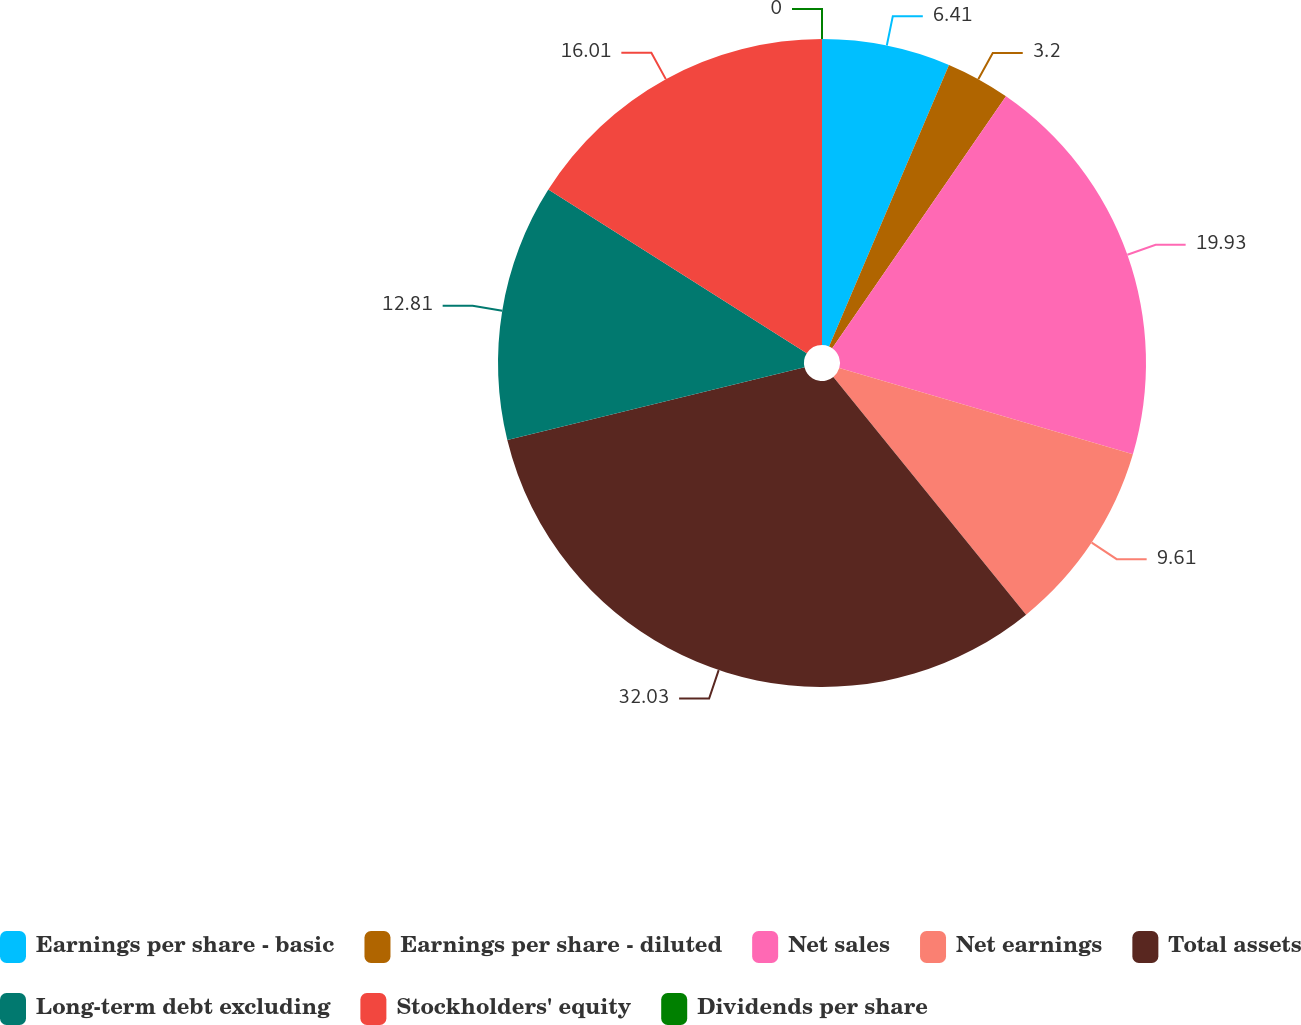<chart> <loc_0><loc_0><loc_500><loc_500><pie_chart><fcel>Earnings per share - basic<fcel>Earnings per share - diluted<fcel>Net sales<fcel>Net earnings<fcel>Total assets<fcel>Long-term debt excluding<fcel>Stockholders' equity<fcel>Dividends per share<nl><fcel>6.41%<fcel>3.2%<fcel>19.93%<fcel>9.61%<fcel>32.02%<fcel>12.81%<fcel>16.01%<fcel>0.0%<nl></chart> 